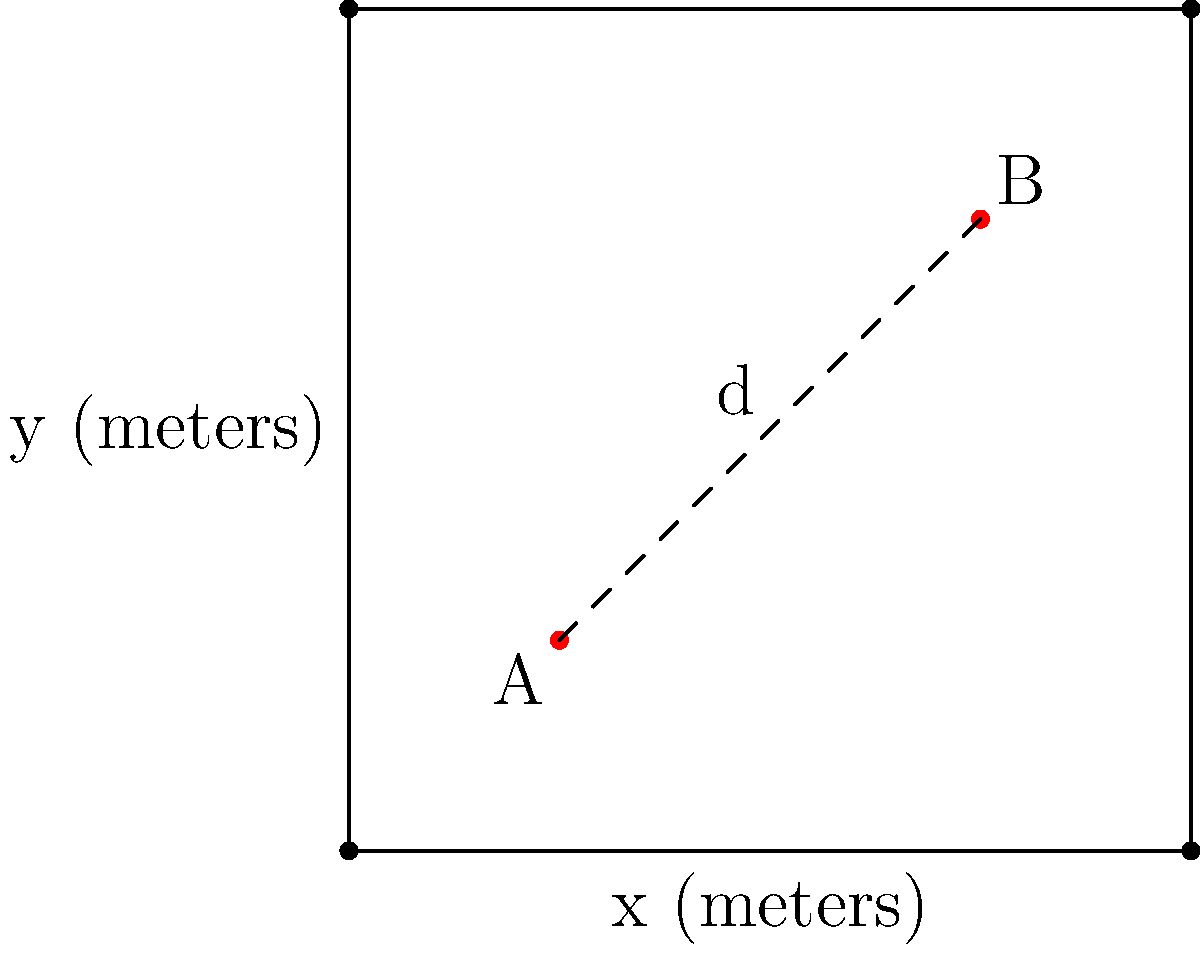In a square neighborhood measuring 100 meters on each side, two street performers (A and B) want to set up their acts. To avoid sound interference, they need to maintain a minimum distance of 60 meters between them. If performer A is located at coordinates (25, 25), what is the minimum x-coordinate where performer B can set up, assuming they are both on the same diagonal line from the southwest corner to the northeast corner of the neighborhood? Let's approach this step-by-step:

1) First, we need to understand that the performers are on the diagonal line from (0,0) to (100,100).

2) We know that performer A is at (25, 25).

3) Let's say performer B is at (x, x), since they're on the same diagonal.

4) We can use the distance formula to set up an equation:
   $\sqrt{(x-25)^2 + (x-25)^2} = 60$

5) Simplify inside the square root:
   $\sqrt{2(x-25)^2} = 60$

6) Square both sides:
   $2(x-25)^2 = 3600$

7) Divide by 2:
   $(x-25)^2 = 1800$

8) Take the square root of both sides:
   $x-25 = \sqrt{1800} \approx 42.43$

9) Solve for x:
   $x = 25 + 42.43 = 67.43$

10) Since we're asked for the minimum x-coordinate and we're rounding to the nearest whole number, we round up to ensure the minimum distance is maintained.

Therefore, the minimum x-coordinate for performer B is 68 meters.
Answer: 68 meters 